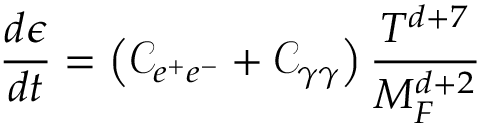Convert formula to latex. <formula><loc_0><loc_0><loc_500><loc_500>\frac { d \epsilon } { d t } = \left ( { \mathcal { C } } _ { e ^ { + } e ^ { - } } + { \mathcal { C } } _ { \gamma \gamma } \right ) \frac { T ^ { d + 7 } } { M _ { F } ^ { d + 2 } }</formula> 